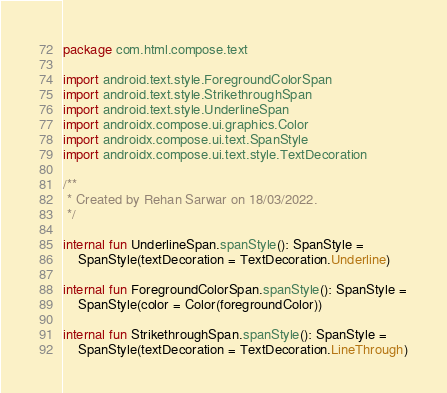<code> <loc_0><loc_0><loc_500><loc_500><_Kotlin_>package com.html.compose.text

import android.text.style.ForegroundColorSpan
import android.text.style.StrikethroughSpan
import android.text.style.UnderlineSpan
import androidx.compose.ui.graphics.Color
import androidx.compose.ui.text.SpanStyle
import androidx.compose.ui.text.style.TextDecoration

/**
 * Created by Rehan Sarwar on 18/03/2022.
 */

internal fun UnderlineSpan.spanStyle(): SpanStyle =
    SpanStyle(textDecoration = TextDecoration.Underline)

internal fun ForegroundColorSpan.spanStyle(): SpanStyle =
    SpanStyle(color = Color(foregroundColor))

internal fun StrikethroughSpan.spanStyle(): SpanStyle =
    SpanStyle(textDecoration = TextDecoration.LineThrough)</code> 